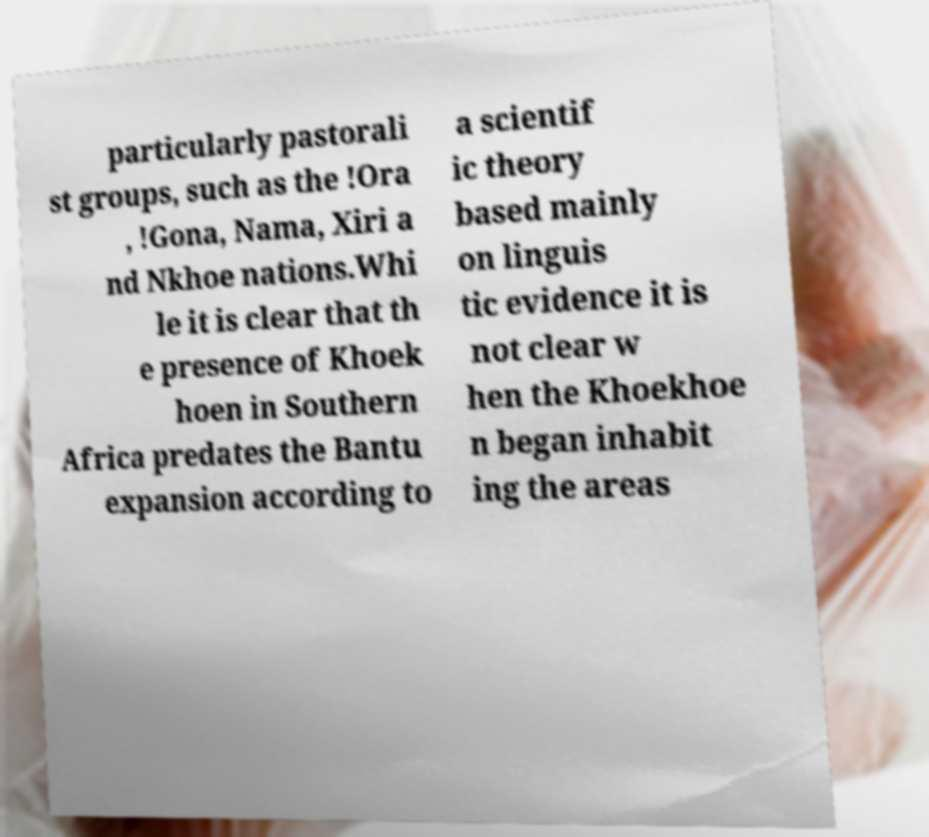Could you assist in decoding the text presented in this image and type it out clearly? particularly pastorali st groups, such as the !Ora , !Gona, Nama, Xiri a nd Nkhoe nations.Whi le it is clear that th e presence of Khoek hoen in Southern Africa predates the Bantu expansion according to a scientif ic theory based mainly on linguis tic evidence it is not clear w hen the Khoekhoe n began inhabit ing the areas 